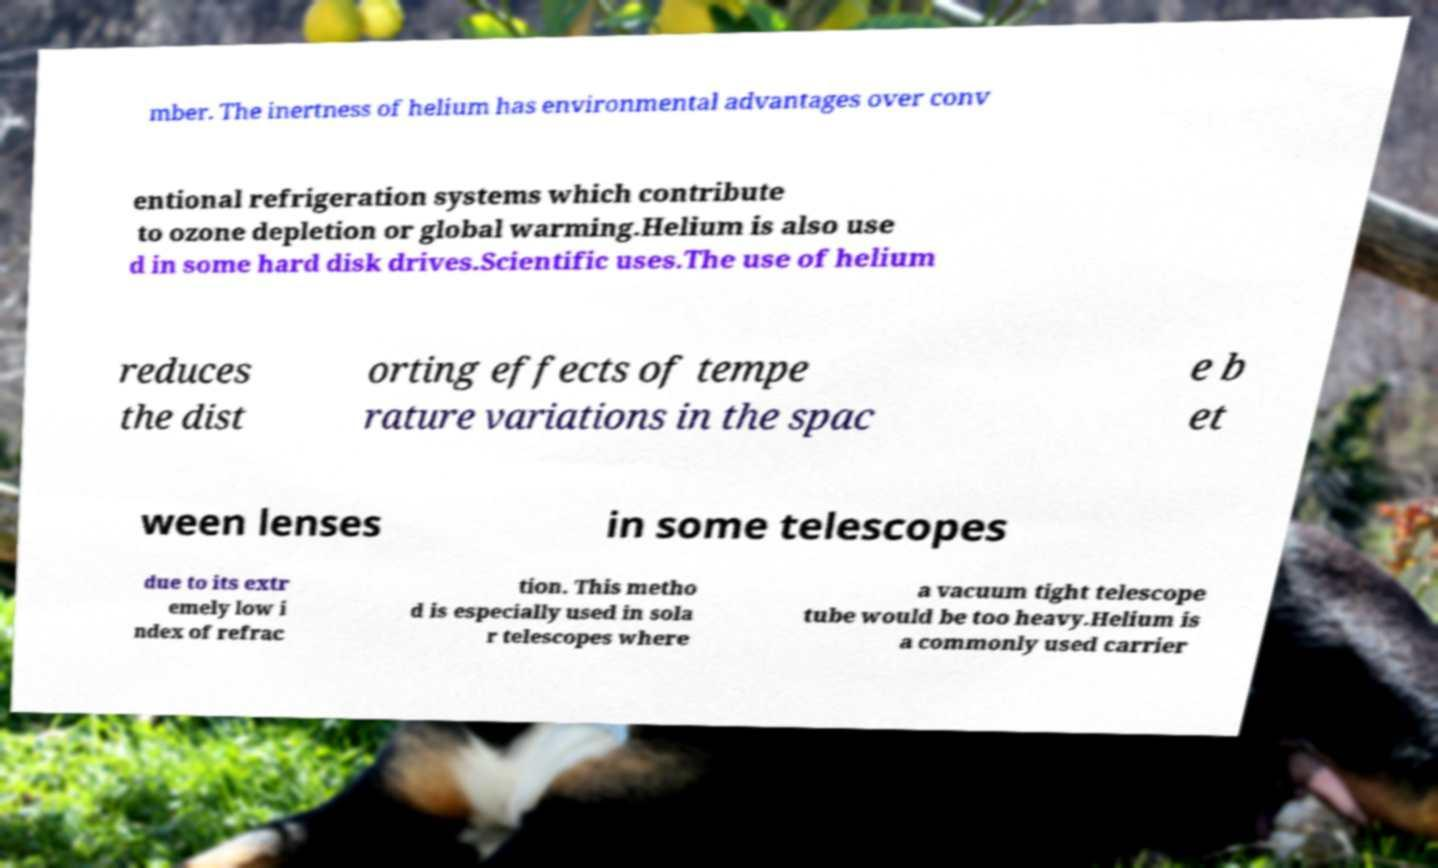Could you extract and type out the text from this image? mber. The inertness of helium has environmental advantages over conv entional refrigeration systems which contribute to ozone depletion or global warming.Helium is also use d in some hard disk drives.Scientific uses.The use of helium reduces the dist orting effects of tempe rature variations in the spac e b et ween lenses in some telescopes due to its extr emely low i ndex of refrac tion. This metho d is especially used in sola r telescopes where a vacuum tight telescope tube would be too heavy.Helium is a commonly used carrier 